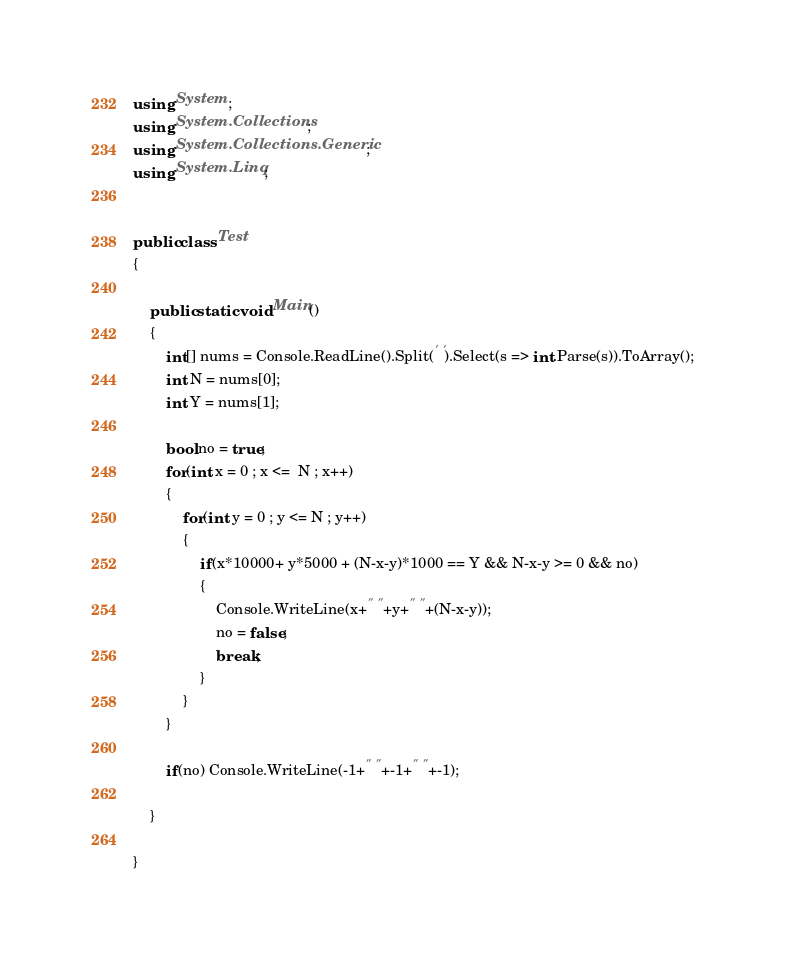Convert code to text. <code><loc_0><loc_0><loc_500><loc_500><_C#_>using System;
using System.Collections;
using System.Collections.Generic;
using System.Linq;


public class Test
{

	public static void Main()
	{
        int[] nums = Console.ReadLine().Split(' ').Select(s => int.Parse(s)).ToArray();
        int N = nums[0];
        int Y = nums[1];
        
        bool no = true;
        for(int x = 0 ; x <=  N ; x++)
        {
            for(int y = 0 ; y <= N ; y++)
            {
                if(x*10000+ y*5000 + (N-x-y)*1000 == Y && N-x-y >= 0 && no)
                {
                    Console.WriteLine(x+" "+y+" "+(N-x-y));
                    no = false;
                    break;
                }
            }
        }
        
        if(no) Console.WriteLine(-1+" "+-1+" "+-1);

    }

}</code> 